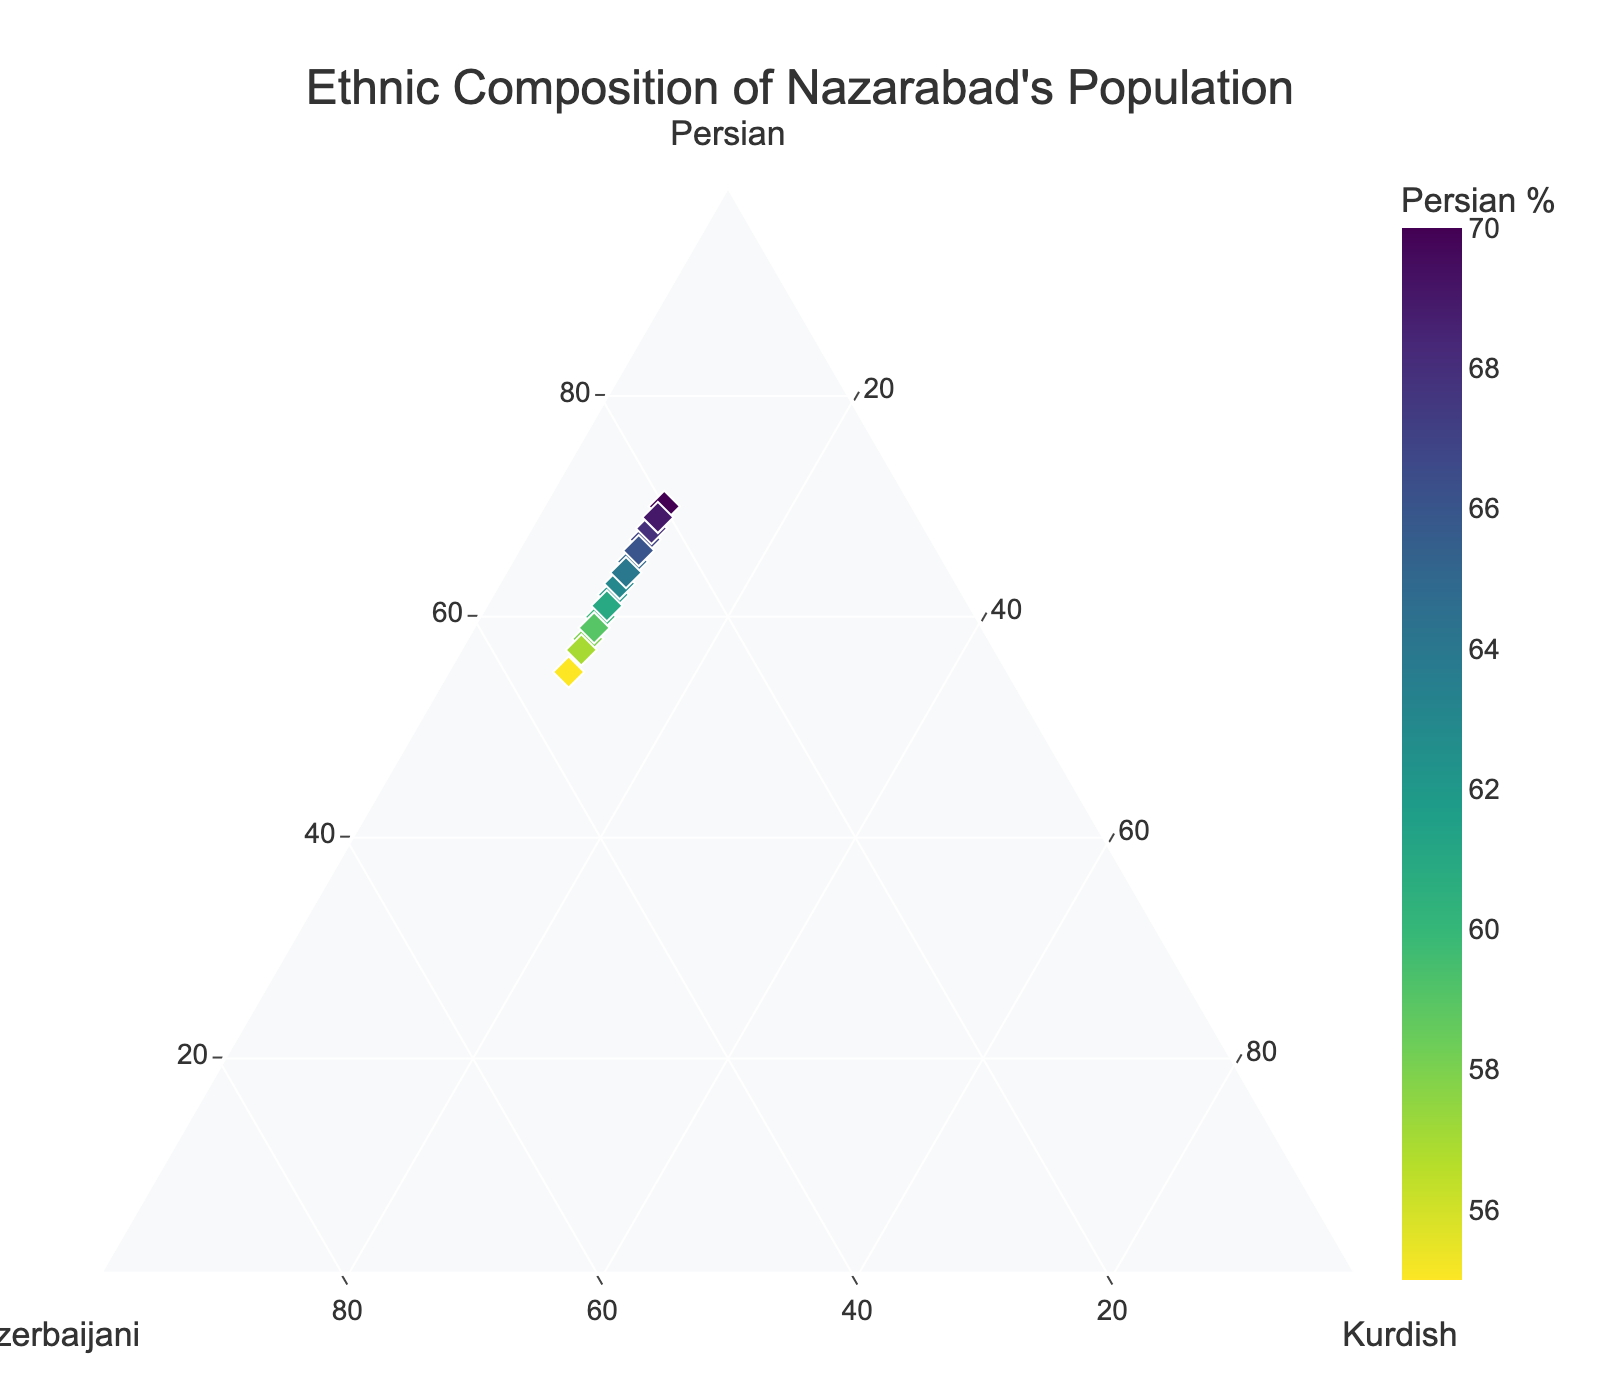How many total data points are displayed in the ternary plot? The number of data points can be counted directly from the plot. There are 15 data points visible on the plot.
Answer: 15 What is the title of the ternary plot? The title is clearly displayed at the top of the plot. It reads "Ethnic Composition of Nazarabad's Population".
Answer: Ethnic Composition of Nazarabad's Population What's the range of percentages for the Persian ethnicity in the data points? By examining the color scale and the values for the 'a' component (Persian), we see that they range from 55% to 70%.
Answer: 55% to 70% Which ethnicity has a consistent percentage value across all data points? By observing the data labels and noticing which percentage remains unchanged, it's evident that the Kurdish percentage is always 10%.
Answer: Kurdish What is the difference between the highest and lowest Persian percentages in the dataset? The highest Persian percentage is 70%, and the lowest is 55%. The difference is calculated as 70 - 55.
Answer: 15% How does the average percentage of Azerbaijani population compare to the average percentage of Persian population? To determine this, we calculate the average for both groups from the provided data. The average percentage values would be approximately 27% for Azerbaijani and 63% for Persian. Comparing these averages tells us that the Persian average is higher.
Answer: Persian average is higher Among the data points, which combination has the highest Persian percentage? By looking through the data points and identifying the one with the highest value for 'Persian', we find it is 70% Persian, 20% Azerbaijani, and 10% Kurdish.
Answer: 70% Persian, 20% Azerbaijani, 10% Kurdish Which data point has the highest Azerbaijani percentage, and what is its corresponding Persian percentage? By looking through the data points and identifying the one with the highest Azerbaijani value, we find it is 55% Persian, 35% Azerbaijani, and 10% Kurdish.
Answer: 55% Persian Are there more data points closer to the Persian apex than the Azerbaijani apex? To answer this, we observe the distribution of points relative to the Persian and Azerbaijani axes within the ternary plot. The majority of points are indeed closer to the Persian apex.
Answer: Yes What can be inferred about the Kurdish population distribution from this ternary plot? The Kurdish percentage is consistent at 10% in all data points, indicating a uniform distribution.
Answer: Uniform at 10% 